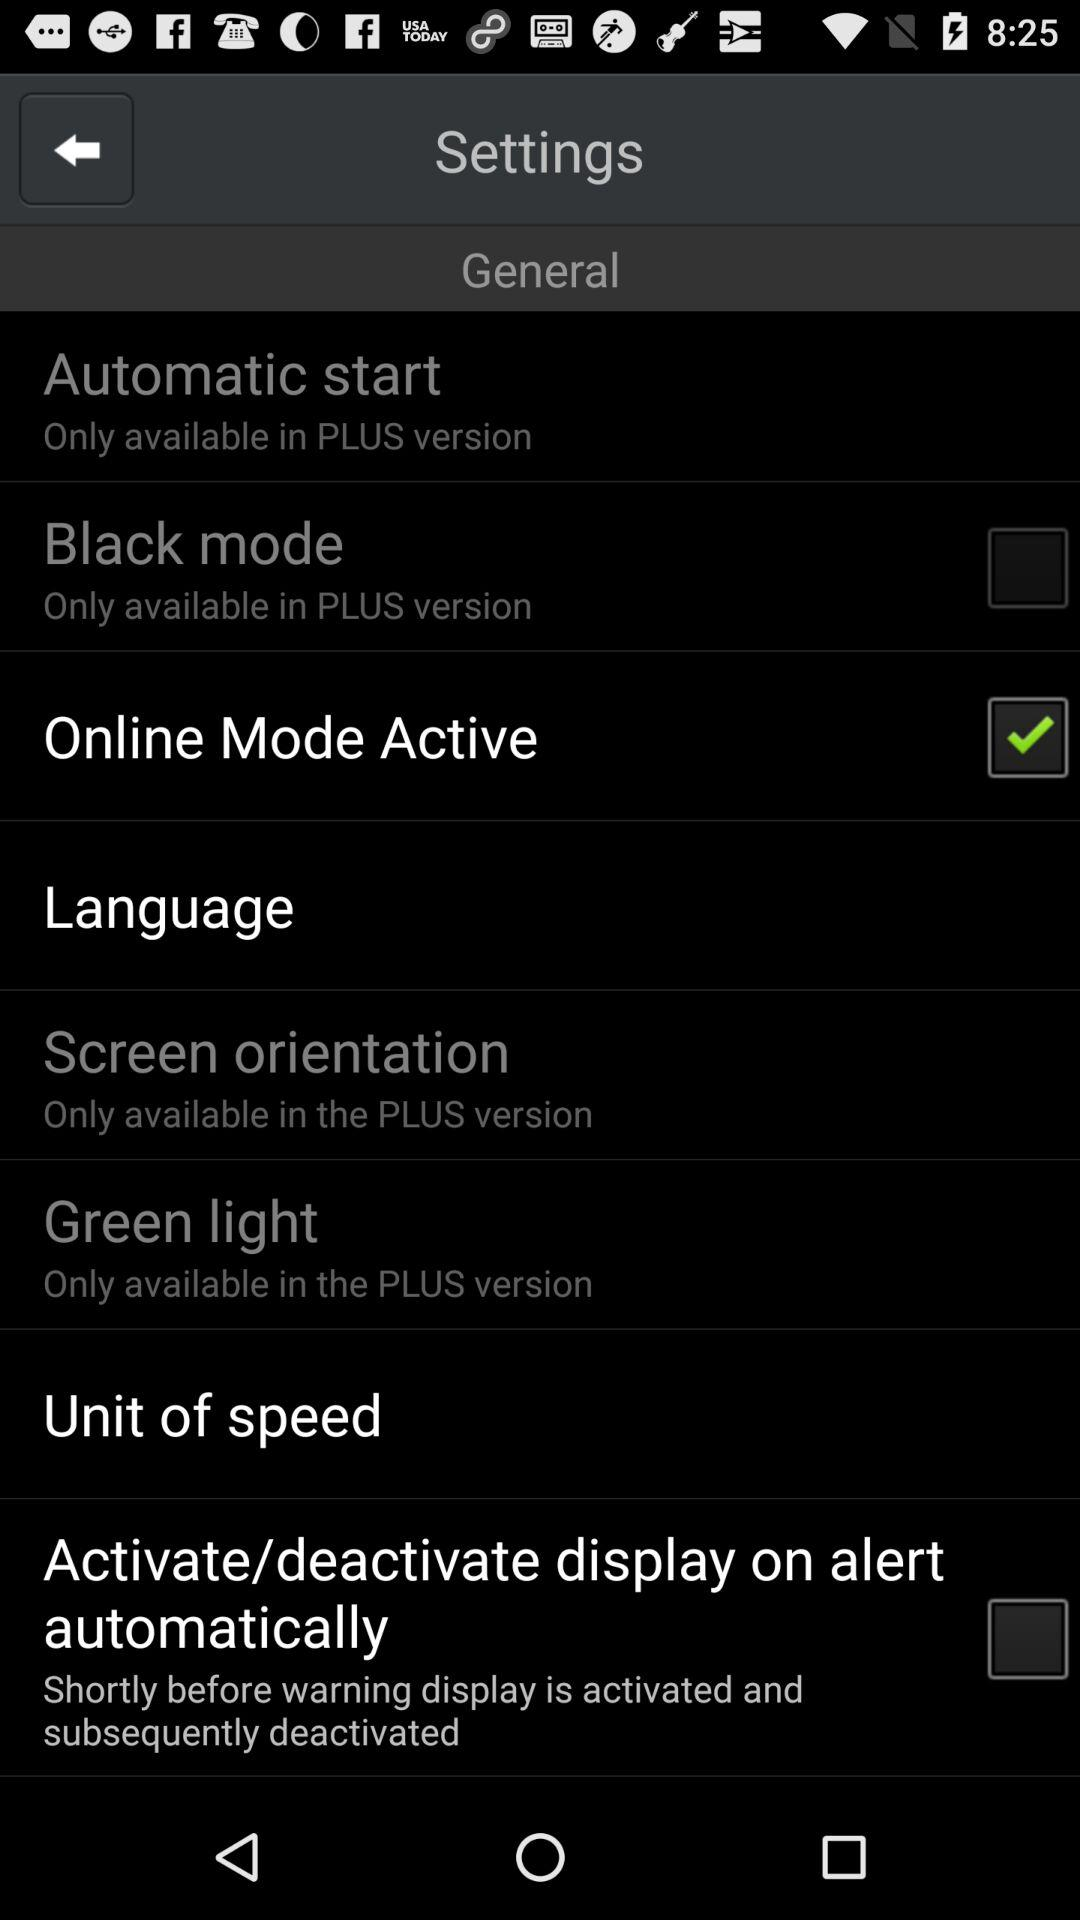Which option has been marked as checked? The option "Online Mode Active" has been marked as checked. 